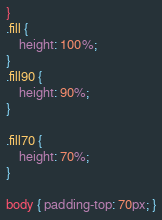<code> <loc_0><loc_0><loc_500><loc_500><_CSS_>}
.fill {
    height: 100%;
}
.fill90 {
    height: 90%;
}

.fill70 {
    height: 70%;
}

body { padding-top: 70px; }

</code> 